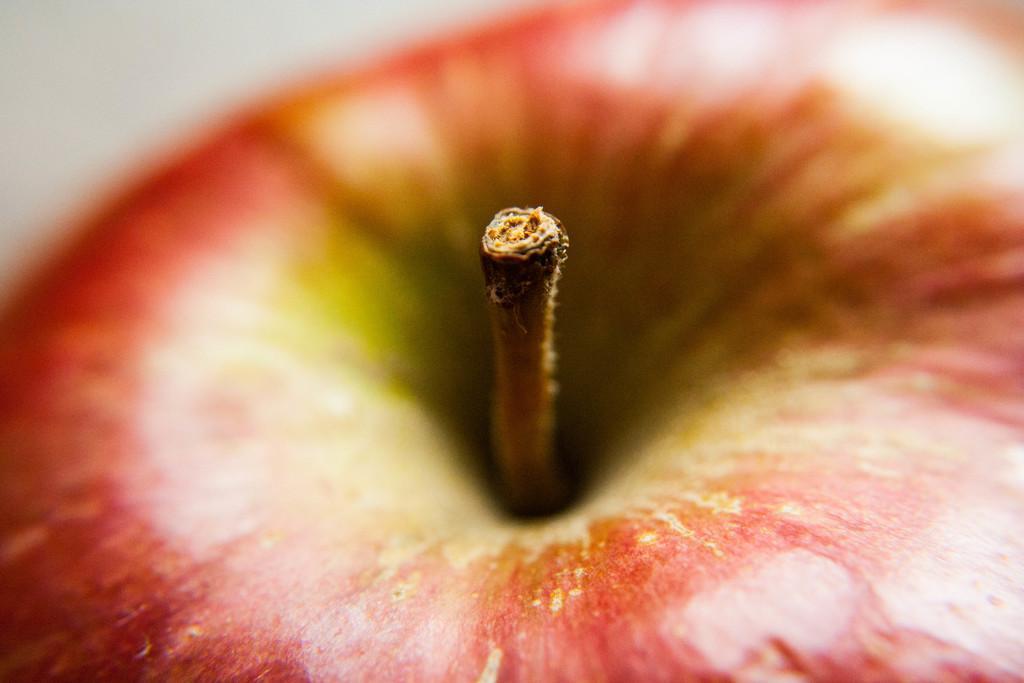How would you summarize this image in a sentence or two? In this picture we can observe an apple which is in red and green color. We can observe a stem of an apple. 